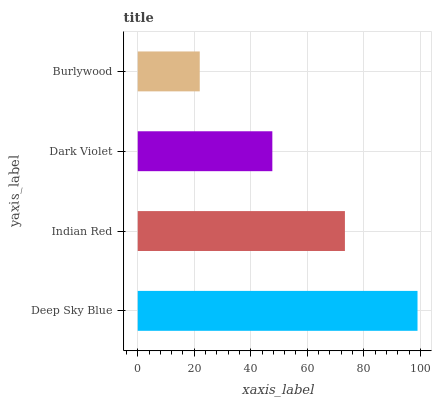Is Burlywood the minimum?
Answer yes or no. Yes. Is Deep Sky Blue the maximum?
Answer yes or no. Yes. Is Indian Red the minimum?
Answer yes or no. No. Is Indian Red the maximum?
Answer yes or no. No. Is Deep Sky Blue greater than Indian Red?
Answer yes or no. Yes. Is Indian Red less than Deep Sky Blue?
Answer yes or no. Yes. Is Indian Red greater than Deep Sky Blue?
Answer yes or no. No. Is Deep Sky Blue less than Indian Red?
Answer yes or no. No. Is Indian Red the high median?
Answer yes or no. Yes. Is Dark Violet the low median?
Answer yes or no. Yes. Is Burlywood the high median?
Answer yes or no. No. Is Deep Sky Blue the low median?
Answer yes or no. No. 